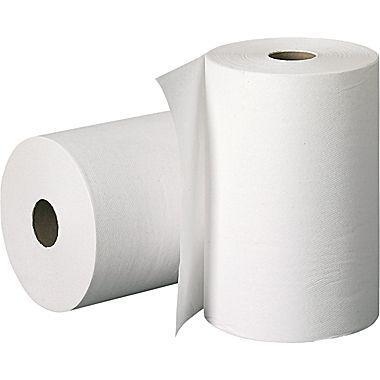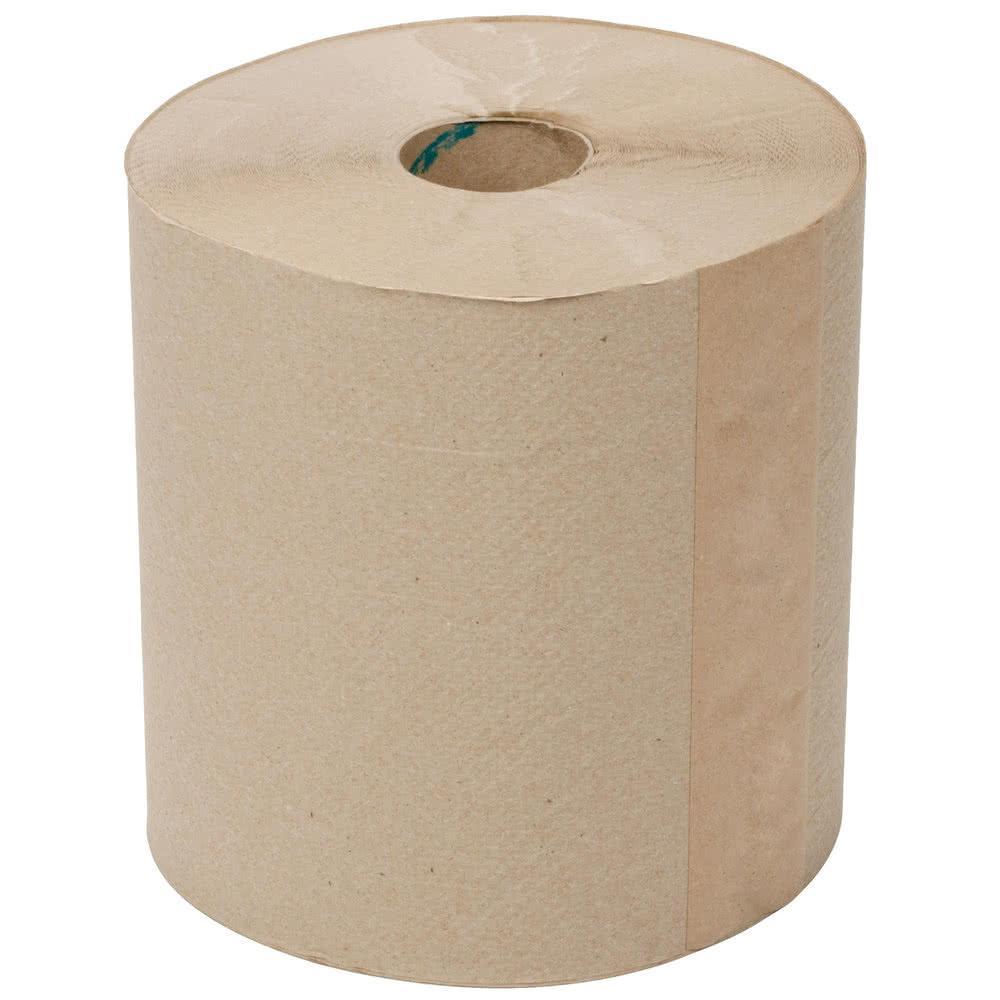The first image is the image on the left, the second image is the image on the right. For the images displayed, is the sentence "There is a brown roll of paper towels in the image on the right." factually correct? Answer yes or no. Yes. 